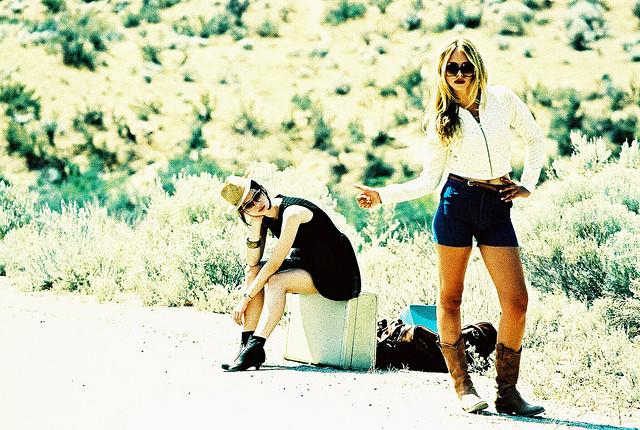What are the women doing on the road?

Choices:
A) waiting
B) sunbathing
C) posing
D) travelling posing 